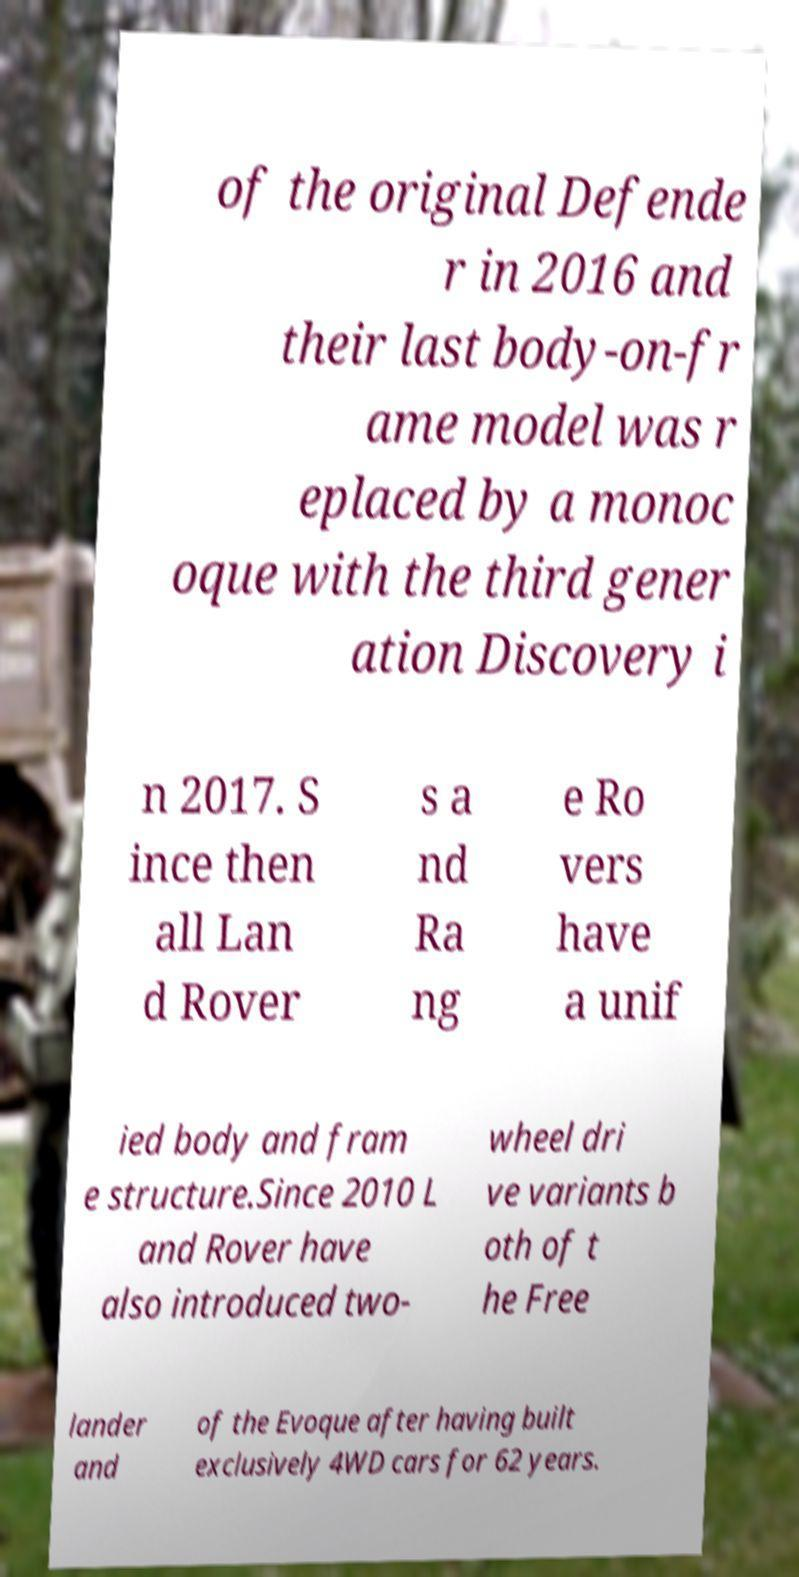There's text embedded in this image that I need extracted. Can you transcribe it verbatim? of the original Defende r in 2016 and their last body-on-fr ame model was r eplaced by a monoc oque with the third gener ation Discovery i n 2017. S ince then all Lan d Rover s a nd Ra ng e Ro vers have a unif ied body and fram e structure.Since 2010 L and Rover have also introduced two- wheel dri ve variants b oth of t he Free lander and of the Evoque after having built exclusively 4WD cars for 62 years. 